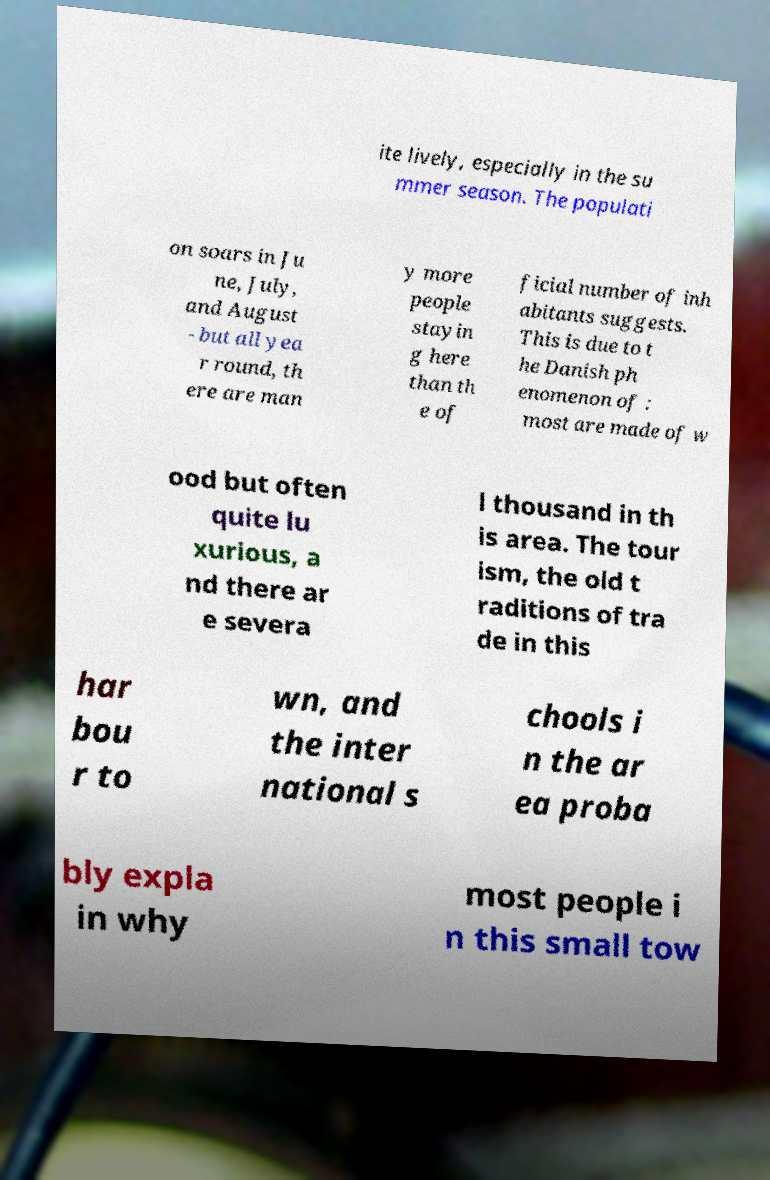There's text embedded in this image that I need extracted. Can you transcribe it verbatim? ite lively, especially in the su mmer season. The populati on soars in Ju ne, July, and August - but all yea r round, th ere are man y more people stayin g here than th e of ficial number of inh abitants suggests. This is due to t he Danish ph enomenon of : most are made of w ood but often quite lu xurious, a nd there ar e severa l thousand in th is area. The tour ism, the old t raditions of tra de in this har bou r to wn, and the inter national s chools i n the ar ea proba bly expla in why most people i n this small tow 